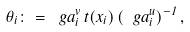<formula> <loc_0><loc_0><loc_500><loc_500>\theta _ { i } \colon = \ g a ^ { v } _ { i } \, t ( x _ { i } ) \, ( \ g a _ { i } ^ { u } ) ^ { - 1 } \, ,</formula> 